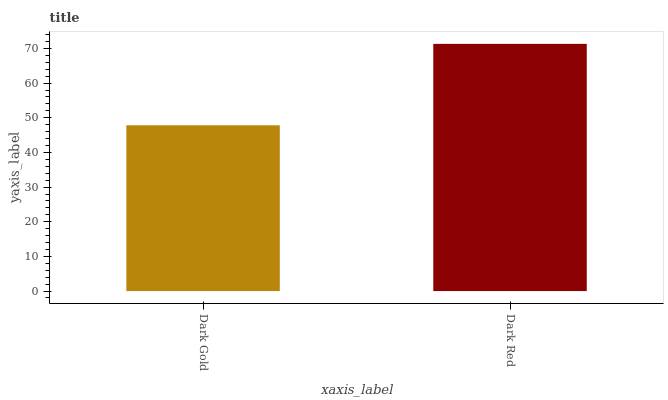Is Dark Gold the minimum?
Answer yes or no. Yes. Is Dark Red the maximum?
Answer yes or no. Yes. Is Dark Red the minimum?
Answer yes or no. No. Is Dark Red greater than Dark Gold?
Answer yes or no. Yes. Is Dark Gold less than Dark Red?
Answer yes or no. Yes. Is Dark Gold greater than Dark Red?
Answer yes or no. No. Is Dark Red less than Dark Gold?
Answer yes or no. No. Is Dark Red the high median?
Answer yes or no. Yes. Is Dark Gold the low median?
Answer yes or no. Yes. Is Dark Gold the high median?
Answer yes or no. No. Is Dark Red the low median?
Answer yes or no. No. 